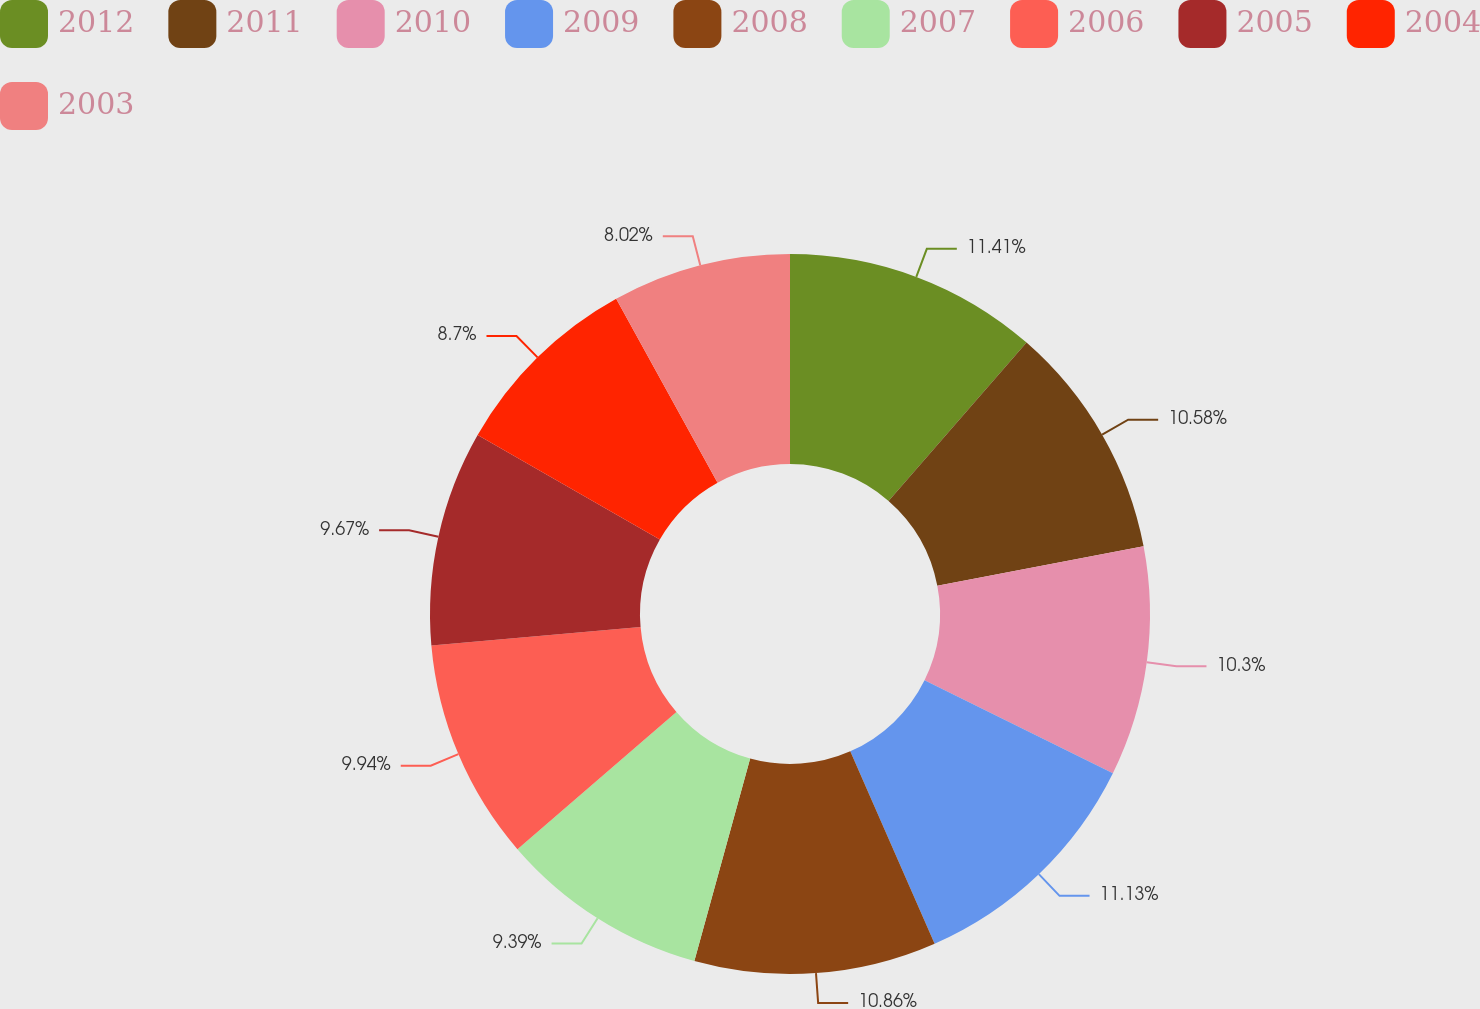Convert chart. <chart><loc_0><loc_0><loc_500><loc_500><pie_chart><fcel>2012<fcel>2011<fcel>2010<fcel>2009<fcel>2008<fcel>2007<fcel>2006<fcel>2005<fcel>2004<fcel>2003<nl><fcel>11.41%<fcel>10.58%<fcel>10.3%<fcel>11.13%<fcel>10.86%<fcel>9.39%<fcel>9.94%<fcel>9.67%<fcel>8.7%<fcel>8.02%<nl></chart> 